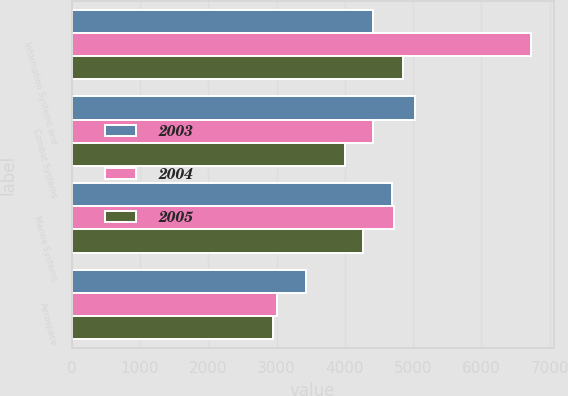Convert chart. <chart><loc_0><loc_0><loc_500><loc_500><stacked_bar_chart><ecel><fcel>Information Systems and<fcel>Combat Systems<fcel>Marine Systems<fcel>Aerospace<nl><fcel>2003<fcel>4407<fcel>5021<fcel>4695<fcel>3433<nl><fcel>2004<fcel>6722<fcel>4407<fcel>4726<fcel>3012<nl><fcel>2005<fcel>4848<fcel>4007<fcel>4271<fcel>2946<nl></chart> 